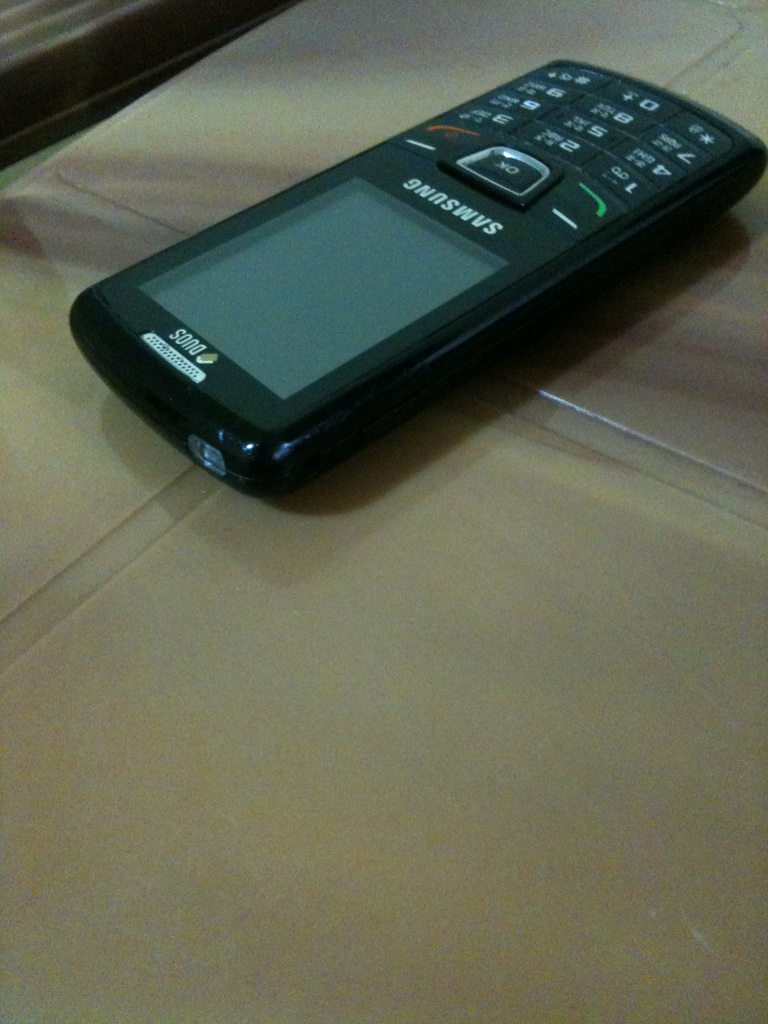What's the significance of a phone like this in today's tech landscape? In today's tech landscape, a phone like this serves a niche market that values minimalism or has specific needs such as limited connectivity for concentration or privacy, or requirement for rugged devices in demanding environments. 